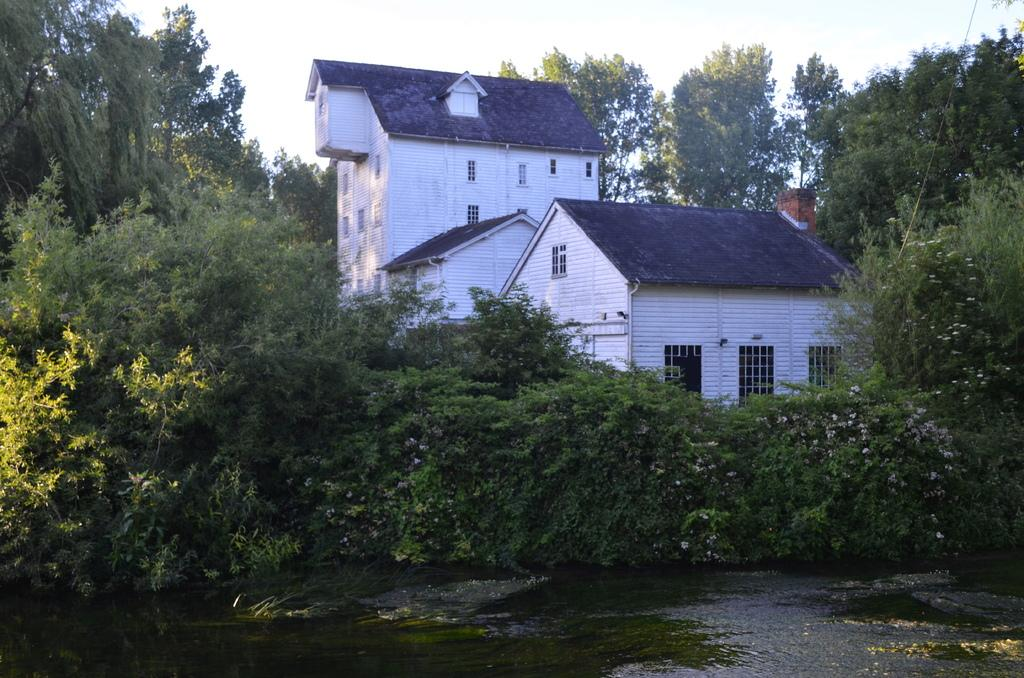What is in the foreground of the image? There is water in the foreground of the image. What can be seen in the middle of the image? There are trees in the middle of the image. What is visible in the background of the image? There are houses in the background of the image. What is visible at the top of the image? The sky is visible at the top of the image. How many chickens are sitting on the chair in the image? There are no chickens or chairs present in the image. What is the value of the painting hanging on the wall in the image? There is no painting or wall visible in the image. 